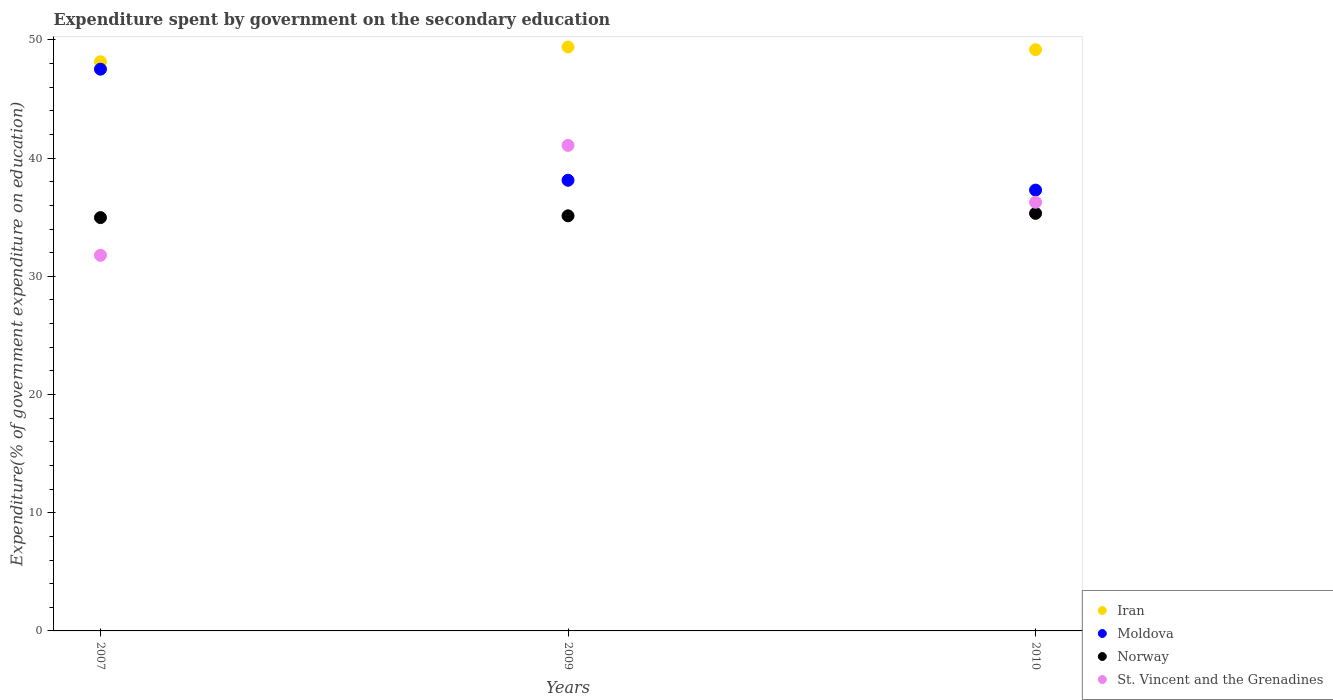Is the number of dotlines equal to the number of legend labels?
Provide a succinct answer. Yes. What is the expenditure spent by government on the secondary education in Moldova in 2010?
Provide a succinct answer. 37.3. Across all years, what is the maximum expenditure spent by government on the secondary education in Moldova?
Your response must be concise. 47.53. Across all years, what is the minimum expenditure spent by government on the secondary education in Norway?
Provide a succinct answer. 34.97. What is the total expenditure spent by government on the secondary education in St. Vincent and the Grenadines in the graph?
Your answer should be compact. 109.14. What is the difference between the expenditure spent by government on the secondary education in Iran in 2007 and that in 2010?
Keep it short and to the point. -1.02. What is the difference between the expenditure spent by government on the secondary education in Norway in 2007 and the expenditure spent by government on the secondary education in Iran in 2009?
Your answer should be very brief. -14.43. What is the average expenditure spent by government on the secondary education in Norway per year?
Give a very brief answer. 35.14. In the year 2007, what is the difference between the expenditure spent by government on the secondary education in Iran and expenditure spent by government on the secondary education in Moldova?
Keep it short and to the point. 0.63. In how many years, is the expenditure spent by government on the secondary education in St. Vincent and the Grenadines greater than 16 %?
Make the answer very short. 3. What is the ratio of the expenditure spent by government on the secondary education in Iran in 2007 to that in 2009?
Give a very brief answer. 0.97. Is the difference between the expenditure spent by government on the secondary education in Iran in 2007 and 2010 greater than the difference between the expenditure spent by government on the secondary education in Moldova in 2007 and 2010?
Your response must be concise. No. What is the difference between the highest and the second highest expenditure spent by government on the secondary education in St. Vincent and the Grenadines?
Your answer should be very brief. 4.82. What is the difference between the highest and the lowest expenditure spent by government on the secondary education in Moldova?
Offer a very short reply. 10.23. Is it the case that in every year, the sum of the expenditure spent by government on the secondary education in St. Vincent and the Grenadines and expenditure spent by government on the secondary education in Moldova  is greater than the sum of expenditure spent by government on the secondary education in Norway and expenditure spent by government on the secondary education in Iran?
Ensure brevity in your answer.  No. Is it the case that in every year, the sum of the expenditure spent by government on the secondary education in Moldova and expenditure spent by government on the secondary education in St. Vincent and the Grenadines  is greater than the expenditure spent by government on the secondary education in Iran?
Provide a short and direct response. Yes. Is the expenditure spent by government on the secondary education in Iran strictly greater than the expenditure spent by government on the secondary education in St. Vincent and the Grenadines over the years?
Give a very brief answer. Yes. Is the expenditure spent by government on the secondary education in Iran strictly less than the expenditure spent by government on the secondary education in Norway over the years?
Your answer should be compact. No. How many dotlines are there?
Your answer should be very brief. 4. What is the difference between two consecutive major ticks on the Y-axis?
Provide a succinct answer. 10. Are the values on the major ticks of Y-axis written in scientific E-notation?
Your answer should be very brief. No. Does the graph contain any zero values?
Make the answer very short. No. Does the graph contain grids?
Keep it short and to the point. No. Where does the legend appear in the graph?
Your answer should be very brief. Bottom right. What is the title of the graph?
Your answer should be compact. Expenditure spent by government on the secondary education. What is the label or title of the Y-axis?
Make the answer very short. Expenditure(% of government expenditure on education). What is the Expenditure(% of government expenditure on education) of Iran in 2007?
Provide a succinct answer. 48.16. What is the Expenditure(% of government expenditure on education) of Moldova in 2007?
Keep it short and to the point. 47.53. What is the Expenditure(% of government expenditure on education) in Norway in 2007?
Make the answer very short. 34.97. What is the Expenditure(% of government expenditure on education) of St. Vincent and the Grenadines in 2007?
Your response must be concise. 31.78. What is the Expenditure(% of government expenditure on education) of Iran in 2009?
Your answer should be very brief. 49.41. What is the Expenditure(% of government expenditure on education) in Moldova in 2009?
Make the answer very short. 38.13. What is the Expenditure(% of government expenditure on education) in Norway in 2009?
Give a very brief answer. 35.12. What is the Expenditure(% of government expenditure on education) of St. Vincent and the Grenadines in 2009?
Offer a terse response. 41.08. What is the Expenditure(% of government expenditure on education) in Iran in 2010?
Your answer should be very brief. 49.18. What is the Expenditure(% of government expenditure on education) of Moldova in 2010?
Ensure brevity in your answer.  37.3. What is the Expenditure(% of government expenditure on education) of Norway in 2010?
Provide a succinct answer. 35.33. What is the Expenditure(% of government expenditure on education) in St. Vincent and the Grenadines in 2010?
Give a very brief answer. 36.27. Across all years, what is the maximum Expenditure(% of government expenditure on education) of Iran?
Provide a succinct answer. 49.41. Across all years, what is the maximum Expenditure(% of government expenditure on education) of Moldova?
Provide a succinct answer. 47.53. Across all years, what is the maximum Expenditure(% of government expenditure on education) of Norway?
Your response must be concise. 35.33. Across all years, what is the maximum Expenditure(% of government expenditure on education) of St. Vincent and the Grenadines?
Offer a terse response. 41.08. Across all years, what is the minimum Expenditure(% of government expenditure on education) of Iran?
Provide a succinct answer. 48.16. Across all years, what is the minimum Expenditure(% of government expenditure on education) of Moldova?
Offer a very short reply. 37.3. Across all years, what is the minimum Expenditure(% of government expenditure on education) of Norway?
Your answer should be compact. 34.97. Across all years, what is the minimum Expenditure(% of government expenditure on education) in St. Vincent and the Grenadines?
Your answer should be compact. 31.78. What is the total Expenditure(% of government expenditure on education) of Iran in the graph?
Make the answer very short. 146.75. What is the total Expenditure(% of government expenditure on education) in Moldova in the graph?
Keep it short and to the point. 122.96. What is the total Expenditure(% of government expenditure on education) in Norway in the graph?
Keep it short and to the point. 105.43. What is the total Expenditure(% of government expenditure on education) in St. Vincent and the Grenadines in the graph?
Offer a very short reply. 109.14. What is the difference between the Expenditure(% of government expenditure on education) of Iran in 2007 and that in 2009?
Make the answer very short. -1.25. What is the difference between the Expenditure(% of government expenditure on education) of Moldova in 2007 and that in 2009?
Make the answer very short. 9.4. What is the difference between the Expenditure(% of government expenditure on education) of Norway in 2007 and that in 2009?
Make the answer very short. -0.15. What is the difference between the Expenditure(% of government expenditure on education) in St. Vincent and the Grenadines in 2007 and that in 2009?
Give a very brief answer. -9.3. What is the difference between the Expenditure(% of government expenditure on education) of Iran in 2007 and that in 2010?
Your answer should be very brief. -1.02. What is the difference between the Expenditure(% of government expenditure on education) in Moldova in 2007 and that in 2010?
Provide a succinct answer. 10.23. What is the difference between the Expenditure(% of government expenditure on education) in Norway in 2007 and that in 2010?
Offer a terse response. -0.36. What is the difference between the Expenditure(% of government expenditure on education) of St. Vincent and the Grenadines in 2007 and that in 2010?
Offer a terse response. -4.49. What is the difference between the Expenditure(% of government expenditure on education) in Iran in 2009 and that in 2010?
Give a very brief answer. 0.23. What is the difference between the Expenditure(% of government expenditure on education) of Moldova in 2009 and that in 2010?
Ensure brevity in your answer.  0.84. What is the difference between the Expenditure(% of government expenditure on education) of Norway in 2009 and that in 2010?
Offer a very short reply. -0.21. What is the difference between the Expenditure(% of government expenditure on education) of St. Vincent and the Grenadines in 2009 and that in 2010?
Your answer should be very brief. 4.82. What is the difference between the Expenditure(% of government expenditure on education) in Iran in 2007 and the Expenditure(% of government expenditure on education) in Moldova in 2009?
Your answer should be very brief. 10.03. What is the difference between the Expenditure(% of government expenditure on education) of Iran in 2007 and the Expenditure(% of government expenditure on education) of Norway in 2009?
Give a very brief answer. 13.04. What is the difference between the Expenditure(% of government expenditure on education) in Iran in 2007 and the Expenditure(% of government expenditure on education) in St. Vincent and the Grenadines in 2009?
Give a very brief answer. 7.08. What is the difference between the Expenditure(% of government expenditure on education) in Moldova in 2007 and the Expenditure(% of government expenditure on education) in Norway in 2009?
Your response must be concise. 12.41. What is the difference between the Expenditure(% of government expenditure on education) in Moldova in 2007 and the Expenditure(% of government expenditure on education) in St. Vincent and the Grenadines in 2009?
Keep it short and to the point. 6.45. What is the difference between the Expenditure(% of government expenditure on education) of Norway in 2007 and the Expenditure(% of government expenditure on education) of St. Vincent and the Grenadines in 2009?
Your answer should be compact. -6.11. What is the difference between the Expenditure(% of government expenditure on education) in Iran in 2007 and the Expenditure(% of government expenditure on education) in Moldova in 2010?
Give a very brief answer. 10.86. What is the difference between the Expenditure(% of government expenditure on education) in Iran in 2007 and the Expenditure(% of government expenditure on education) in Norway in 2010?
Your answer should be very brief. 12.83. What is the difference between the Expenditure(% of government expenditure on education) in Iran in 2007 and the Expenditure(% of government expenditure on education) in St. Vincent and the Grenadines in 2010?
Ensure brevity in your answer.  11.89. What is the difference between the Expenditure(% of government expenditure on education) of Moldova in 2007 and the Expenditure(% of government expenditure on education) of Norway in 2010?
Make the answer very short. 12.2. What is the difference between the Expenditure(% of government expenditure on education) in Moldova in 2007 and the Expenditure(% of government expenditure on education) in St. Vincent and the Grenadines in 2010?
Make the answer very short. 11.26. What is the difference between the Expenditure(% of government expenditure on education) of Norway in 2007 and the Expenditure(% of government expenditure on education) of St. Vincent and the Grenadines in 2010?
Your answer should be very brief. -1.3. What is the difference between the Expenditure(% of government expenditure on education) in Iran in 2009 and the Expenditure(% of government expenditure on education) in Moldova in 2010?
Offer a very short reply. 12.11. What is the difference between the Expenditure(% of government expenditure on education) in Iran in 2009 and the Expenditure(% of government expenditure on education) in Norway in 2010?
Your answer should be compact. 14.08. What is the difference between the Expenditure(% of government expenditure on education) of Iran in 2009 and the Expenditure(% of government expenditure on education) of St. Vincent and the Grenadines in 2010?
Give a very brief answer. 13.14. What is the difference between the Expenditure(% of government expenditure on education) of Moldova in 2009 and the Expenditure(% of government expenditure on education) of Norway in 2010?
Give a very brief answer. 2.8. What is the difference between the Expenditure(% of government expenditure on education) of Moldova in 2009 and the Expenditure(% of government expenditure on education) of St. Vincent and the Grenadines in 2010?
Your answer should be compact. 1.86. What is the difference between the Expenditure(% of government expenditure on education) of Norway in 2009 and the Expenditure(% of government expenditure on education) of St. Vincent and the Grenadines in 2010?
Provide a short and direct response. -1.15. What is the average Expenditure(% of government expenditure on education) of Iran per year?
Keep it short and to the point. 48.92. What is the average Expenditure(% of government expenditure on education) of Moldova per year?
Provide a short and direct response. 40.99. What is the average Expenditure(% of government expenditure on education) of Norway per year?
Ensure brevity in your answer.  35.14. What is the average Expenditure(% of government expenditure on education) of St. Vincent and the Grenadines per year?
Keep it short and to the point. 36.38. In the year 2007, what is the difference between the Expenditure(% of government expenditure on education) in Iran and Expenditure(% of government expenditure on education) in Moldova?
Ensure brevity in your answer.  0.63. In the year 2007, what is the difference between the Expenditure(% of government expenditure on education) in Iran and Expenditure(% of government expenditure on education) in Norway?
Your response must be concise. 13.19. In the year 2007, what is the difference between the Expenditure(% of government expenditure on education) in Iran and Expenditure(% of government expenditure on education) in St. Vincent and the Grenadines?
Your answer should be very brief. 16.38. In the year 2007, what is the difference between the Expenditure(% of government expenditure on education) of Moldova and Expenditure(% of government expenditure on education) of Norway?
Your response must be concise. 12.56. In the year 2007, what is the difference between the Expenditure(% of government expenditure on education) in Moldova and Expenditure(% of government expenditure on education) in St. Vincent and the Grenadines?
Keep it short and to the point. 15.75. In the year 2007, what is the difference between the Expenditure(% of government expenditure on education) of Norway and Expenditure(% of government expenditure on education) of St. Vincent and the Grenadines?
Your answer should be compact. 3.19. In the year 2009, what is the difference between the Expenditure(% of government expenditure on education) in Iran and Expenditure(% of government expenditure on education) in Moldova?
Your answer should be compact. 11.27. In the year 2009, what is the difference between the Expenditure(% of government expenditure on education) in Iran and Expenditure(% of government expenditure on education) in Norway?
Provide a short and direct response. 14.29. In the year 2009, what is the difference between the Expenditure(% of government expenditure on education) in Iran and Expenditure(% of government expenditure on education) in St. Vincent and the Grenadines?
Keep it short and to the point. 8.32. In the year 2009, what is the difference between the Expenditure(% of government expenditure on education) of Moldova and Expenditure(% of government expenditure on education) of Norway?
Ensure brevity in your answer.  3.01. In the year 2009, what is the difference between the Expenditure(% of government expenditure on education) in Moldova and Expenditure(% of government expenditure on education) in St. Vincent and the Grenadines?
Your answer should be very brief. -2.95. In the year 2009, what is the difference between the Expenditure(% of government expenditure on education) in Norway and Expenditure(% of government expenditure on education) in St. Vincent and the Grenadines?
Offer a very short reply. -5.96. In the year 2010, what is the difference between the Expenditure(% of government expenditure on education) of Iran and Expenditure(% of government expenditure on education) of Moldova?
Make the answer very short. 11.88. In the year 2010, what is the difference between the Expenditure(% of government expenditure on education) in Iran and Expenditure(% of government expenditure on education) in Norway?
Provide a succinct answer. 13.85. In the year 2010, what is the difference between the Expenditure(% of government expenditure on education) of Iran and Expenditure(% of government expenditure on education) of St. Vincent and the Grenadines?
Your response must be concise. 12.91. In the year 2010, what is the difference between the Expenditure(% of government expenditure on education) of Moldova and Expenditure(% of government expenditure on education) of Norway?
Provide a short and direct response. 1.97. In the year 2010, what is the difference between the Expenditure(% of government expenditure on education) in Moldova and Expenditure(% of government expenditure on education) in St. Vincent and the Grenadines?
Your answer should be compact. 1.03. In the year 2010, what is the difference between the Expenditure(% of government expenditure on education) in Norway and Expenditure(% of government expenditure on education) in St. Vincent and the Grenadines?
Your answer should be very brief. -0.94. What is the ratio of the Expenditure(% of government expenditure on education) in Iran in 2007 to that in 2009?
Offer a very short reply. 0.97. What is the ratio of the Expenditure(% of government expenditure on education) of Moldova in 2007 to that in 2009?
Make the answer very short. 1.25. What is the ratio of the Expenditure(% of government expenditure on education) in St. Vincent and the Grenadines in 2007 to that in 2009?
Ensure brevity in your answer.  0.77. What is the ratio of the Expenditure(% of government expenditure on education) in Iran in 2007 to that in 2010?
Provide a short and direct response. 0.98. What is the ratio of the Expenditure(% of government expenditure on education) in Moldova in 2007 to that in 2010?
Make the answer very short. 1.27. What is the ratio of the Expenditure(% of government expenditure on education) of St. Vincent and the Grenadines in 2007 to that in 2010?
Give a very brief answer. 0.88. What is the ratio of the Expenditure(% of government expenditure on education) in Iran in 2009 to that in 2010?
Keep it short and to the point. 1. What is the ratio of the Expenditure(% of government expenditure on education) in Moldova in 2009 to that in 2010?
Ensure brevity in your answer.  1.02. What is the ratio of the Expenditure(% of government expenditure on education) in St. Vincent and the Grenadines in 2009 to that in 2010?
Offer a terse response. 1.13. What is the difference between the highest and the second highest Expenditure(% of government expenditure on education) of Iran?
Provide a short and direct response. 0.23. What is the difference between the highest and the second highest Expenditure(% of government expenditure on education) in Moldova?
Keep it short and to the point. 9.4. What is the difference between the highest and the second highest Expenditure(% of government expenditure on education) in Norway?
Provide a succinct answer. 0.21. What is the difference between the highest and the second highest Expenditure(% of government expenditure on education) in St. Vincent and the Grenadines?
Provide a short and direct response. 4.82. What is the difference between the highest and the lowest Expenditure(% of government expenditure on education) in Iran?
Your response must be concise. 1.25. What is the difference between the highest and the lowest Expenditure(% of government expenditure on education) in Moldova?
Your answer should be very brief. 10.23. What is the difference between the highest and the lowest Expenditure(% of government expenditure on education) of Norway?
Your response must be concise. 0.36. What is the difference between the highest and the lowest Expenditure(% of government expenditure on education) in St. Vincent and the Grenadines?
Offer a terse response. 9.3. 